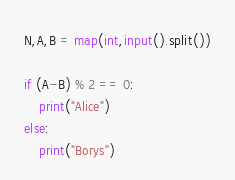<code> <loc_0><loc_0><loc_500><loc_500><_Python_>N,A,B = map(int,input().split())

if (A-B) % 2 == 0:
    print("Alice")
else:
    print("Borys")
</code> 